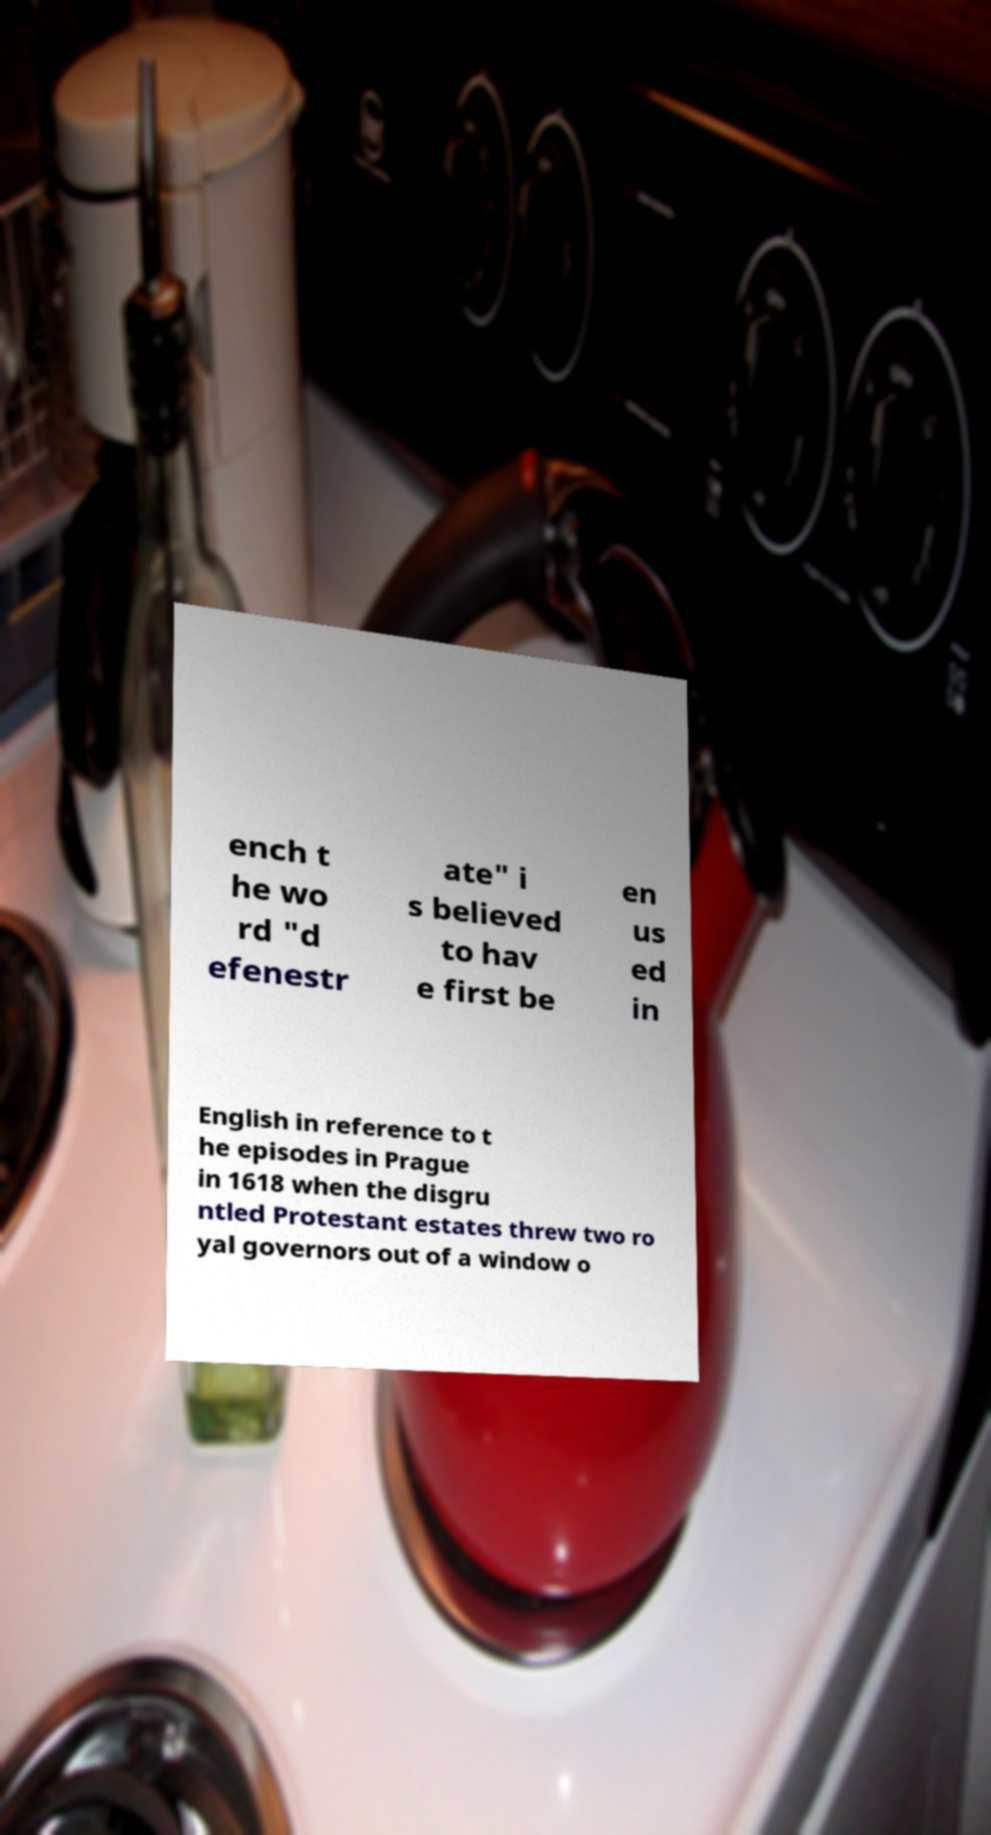Please read and relay the text visible in this image. What does it say? ench t he wo rd "d efenestr ate" i s believed to hav e first be en us ed in English in reference to t he episodes in Prague in 1618 when the disgru ntled Protestant estates threw two ro yal governors out of a window o 